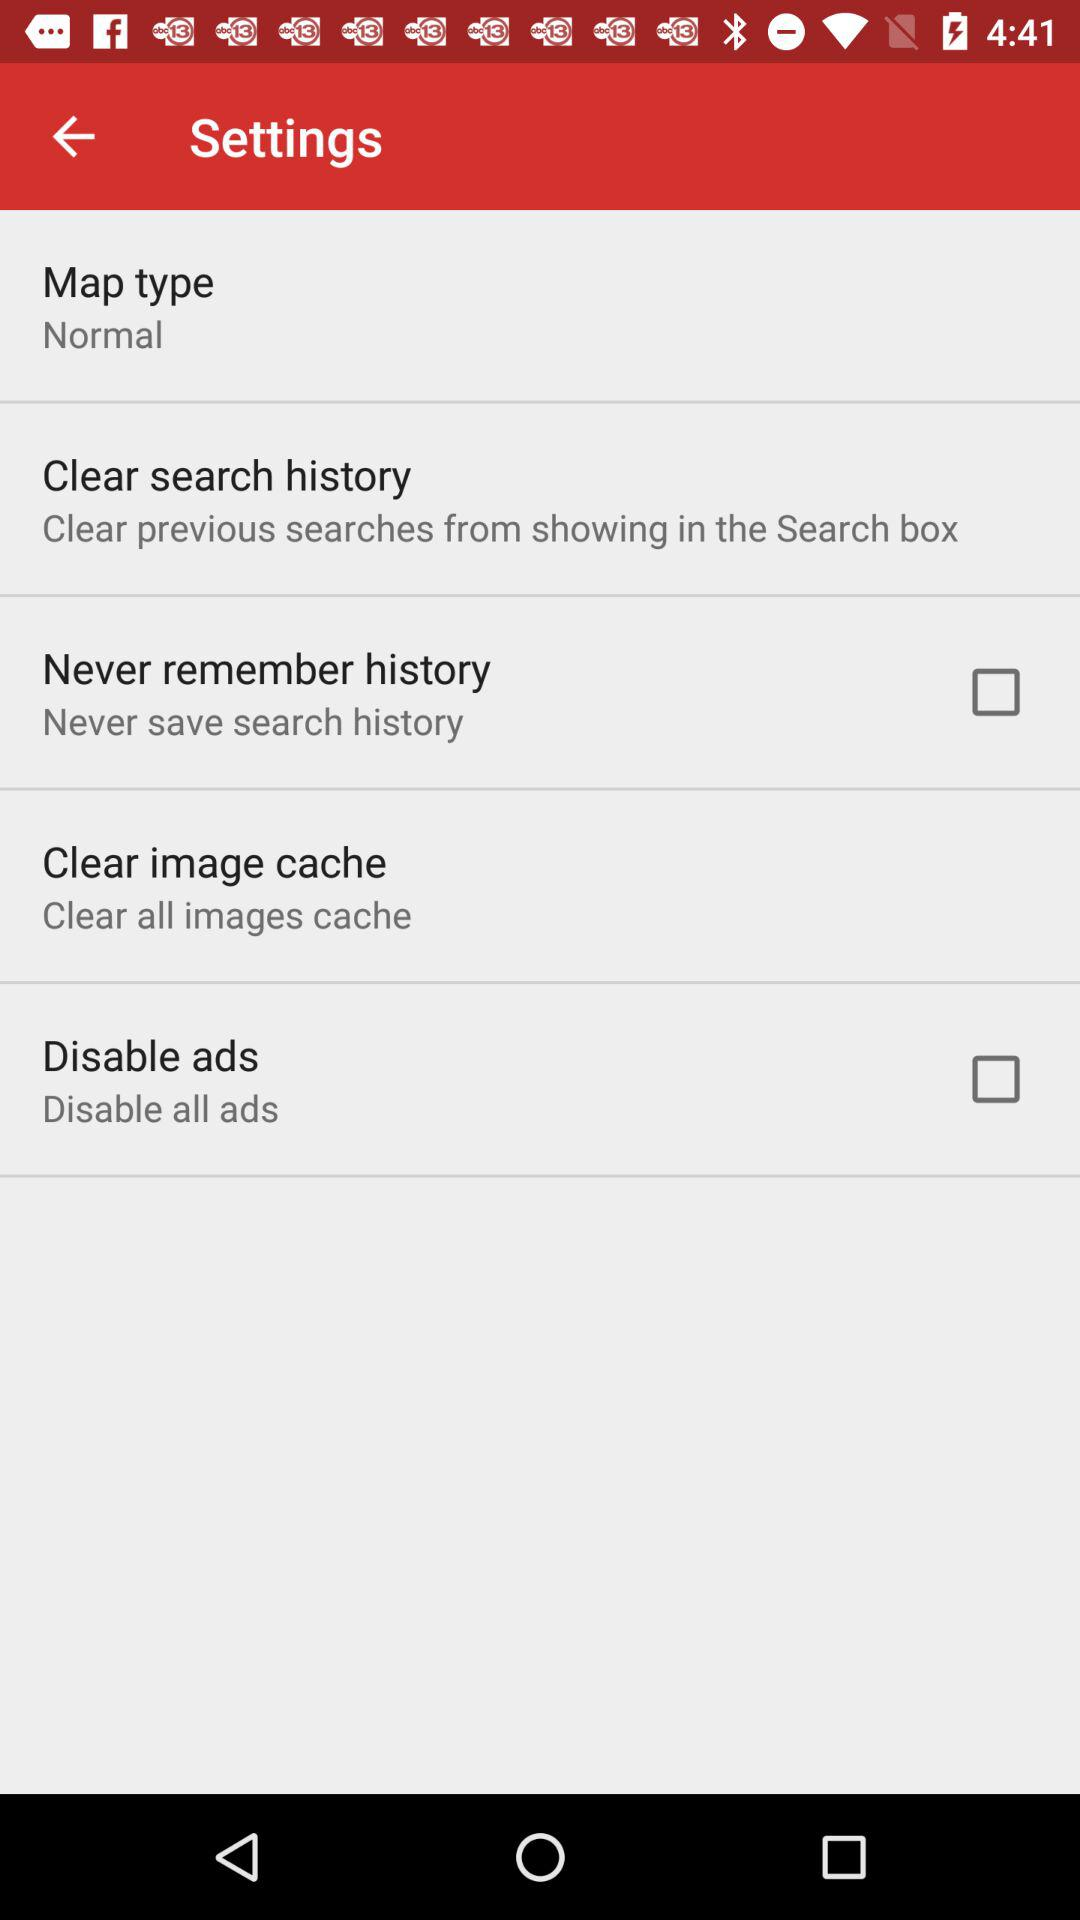What is the status of the "Never remember history"? The status is "off". 